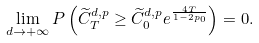<formula> <loc_0><loc_0><loc_500><loc_500>\lim _ { d \rightarrow + \infty } P \left ( \widetilde { C } _ { T } ^ { d , p } \geq \widetilde { C } _ { 0 } ^ { d , p } e ^ { \frac { 4 T } { 1 - 2 p _ { 0 } } } \right ) = 0 .</formula> 